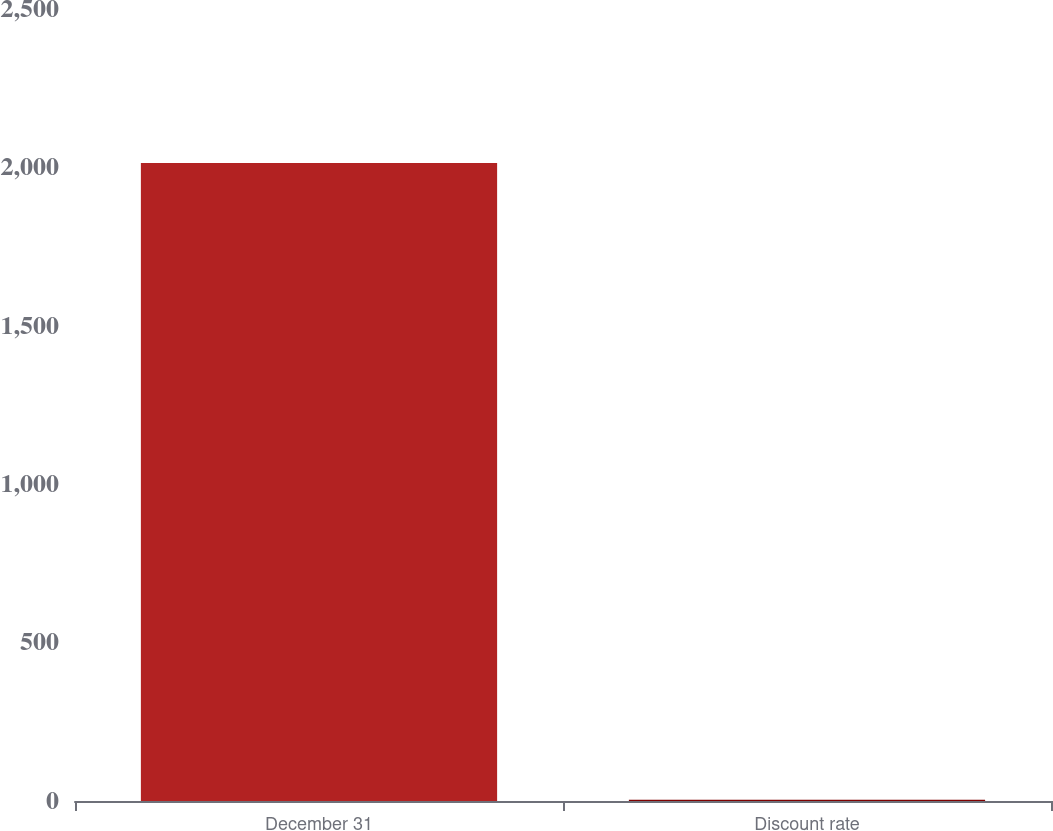Convert chart. <chart><loc_0><loc_0><loc_500><loc_500><bar_chart><fcel>December 31<fcel>Discount rate<nl><fcel>2014<fcel>3.75<nl></chart> 